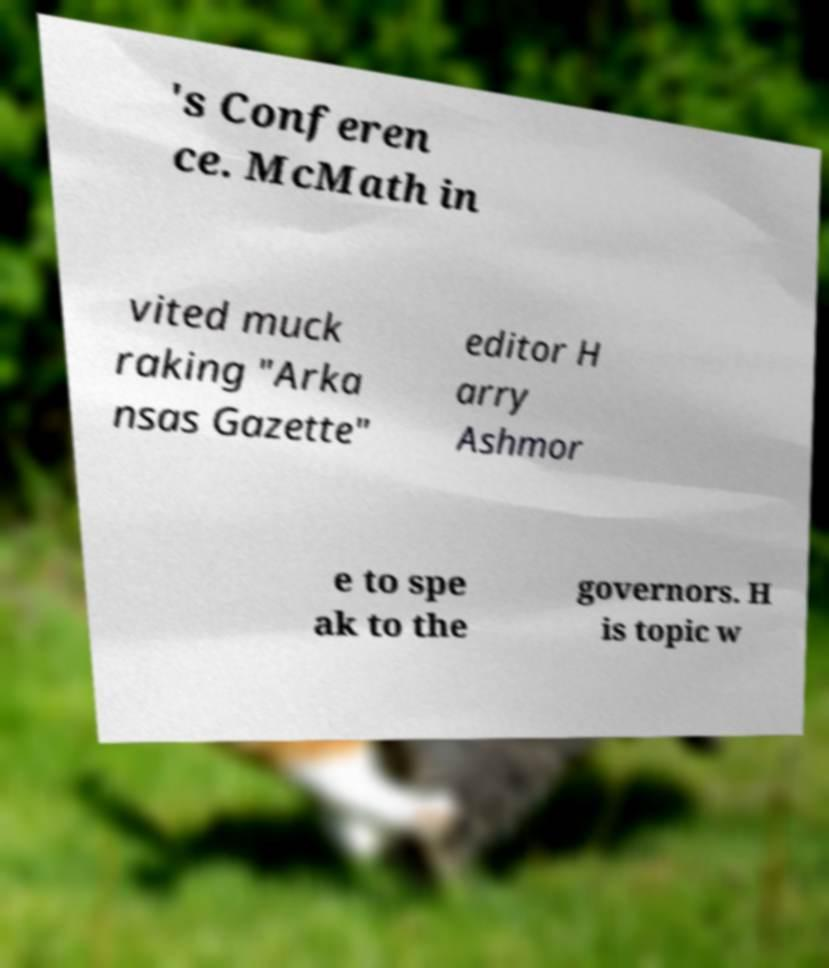There's text embedded in this image that I need extracted. Can you transcribe it verbatim? 's Conferen ce. McMath in vited muck raking "Arka nsas Gazette" editor H arry Ashmor e to spe ak to the governors. H is topic w 